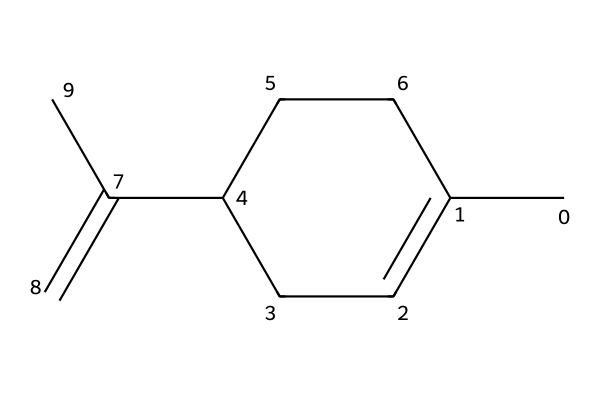What is the molecular formula of limonene? By analyzing the SMILES representation, we can identify that there are 10 carbon (C) atoms and 16 hydrogen (H) atoms. Thus, the molecular formula can be constructed as C10H16.
Answer: C10H16 How many rings are present in limonene? The structure represented by the SMILES indicates a single cycloalkane ring in addition to the double bond. Therefore, there is one ring present in the limonene structure.
Answer: 1 What type of compound is limonene classified as? Limonene contains a cyclic structure and has the presence of a double bond, classifying it as a monoterpene, which is a specific type of terpene.
Answer: monoterpene Does limonene have any double bonds? In the provided structure, the presence of the "C(=C)" notation indicates that there is a double bond located within the structure of limonene.
Answer: yes Which functional group is primarily responsible for limonene's citrus scent? The presence of the double bond (alkene) along with the carbon skeleton contributes significantly to its fragrance properties that are characteristic of citrus compounds.
Answer: alkene How many hydrogen atoms are attached to the carbon atoms in limonene's ring structure? Upon examining the structure, it can be established that three hydrogen atoms are attached to the carbons in the ring. This relates to the saturation of the cycloalkane.
Answer: 3 What is an important application of limonene in pet-friendly products? Limonene is prominently used in natural cleaning products due to its pleasant citrus scent and potential antimicrobial properties, making it a popular choice for pet-safe environments.
Answer: natural cleaning agent 